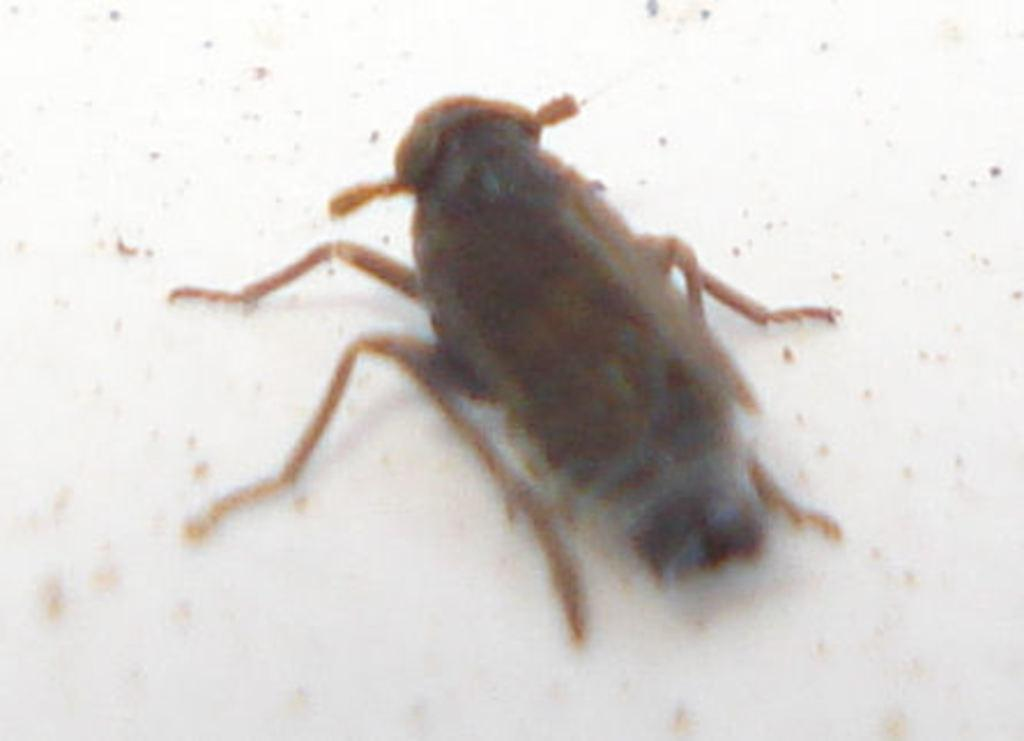What type of insect is present in the image? There is a cockroach in the picture. What object can be seen at the bottom of the image? There is a marble at the bottom of the picture. What type of yarn is being used to create the cockroach's wings in the image? There is no yarn present in the image, and the cockroach's wings are not made of yarn. 